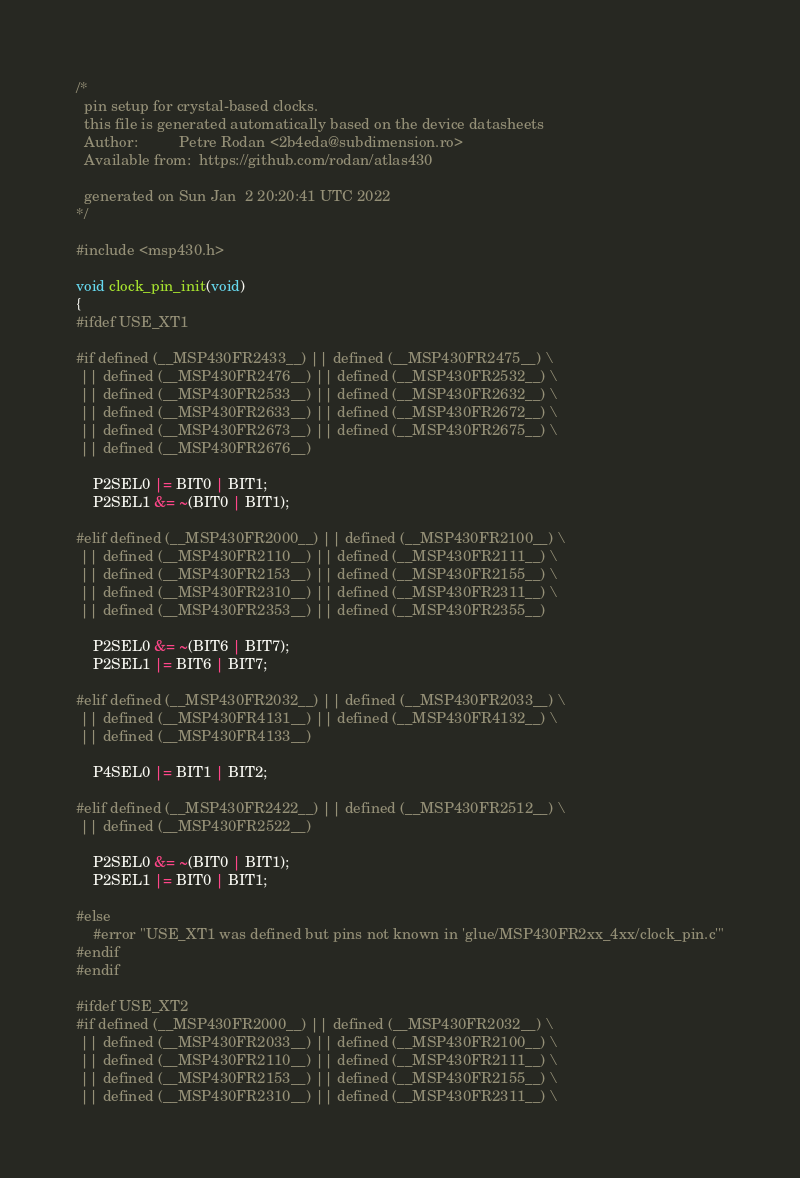<code> <loc_0><loc_0><loc_500><loc_500><_C_>/*
  pin setup for crystal-based clocks. 
  this file is generated automatically based on the device datasheets
  Author:          Petre Rodan <2b4eda@subdimension.ro>
  Available from:  https://github.com/rodan/atlas430

  generated on Sun Jan  2 20:20:41 UTC 2022
*/

#include <msp430.h>

void clock_pin_init(void)
{
#ifdef USE_XT1

#if defined (__MSP430FR2433__) || defined (__MSP430FR2475__) \
 || defined (__MSP430FR2476__) || defined (__MSP430FR2532__) \
 || defined (__MSP430FR2533__) || defined (__MSP430FR2632__) \
 || defined (__MSP430FR2633__) || defined (__MSP430FR2672__) \
 || defined (__MSP430FR2673__) || defined (__MSP430FR2675__) \
 || defined (__MSP430FR2676__)

    P2SEL0 |= BIT0 | BIT1;
    P2SEL1 &= ~(BIT0 | BIT1);

#elif defined (__MSP430FR2000__) || defined (__MSP430FR2100__) \
 || defined (__MSP430FR2110__) || defined (__MSP430FR2111__) \
 || defined (__MSP430FR2153__) || defined (__MSP430FR2155__) \
 || defined (__MSP430FR2310__) || defined (__MSP430FR2311__) \
 || defined (__MSP430FR2353__) || defined (__MSP430FR2355__)

    P2SEL0 &= ~(BIT6 | BIT7);
    P2SEL1 |= BIT6 | BIT7;

#elif defined (__MSP430FR2032__) || defined (__MSP430FR2033__) \
 || defined (__MSP430FR4131__) || defined (__MSP430FR4132__) \
 || defined (__MSP430FR4133__)

    P4SEL0 |= BIT1 | BIT2;

#elif defined (__MSP430FR2422__) || defined (__MSP430FR2512__) \
 || defined (__MSP430FR2522__)

    P2SEL0 &= ~(BIT0 | BIT1);
    P2SEL1 |= BIT0 | BIT1;

#else
    #error "USE_XT1 was defined but pins not known in 'glue/MSP430FR2xx_4xx/clock_pin.c'"
#endif
#endif

#ifdef USE_XT2
#if defined (__MSP430FR2000__) || defined (__MSP430FR2032__) \
 || defined (__MSP430FR2033__) || defined (__MSP430FR2100__) \
 || defined (__MSP430FR2110__) || defined (__MSP430FR2111__) \
 || defined (__MSP430FR2153__) || defined (__MSP430FR2155__) \
 || defined (__MSP430FR2310__) || defined (__MSP430FR2311__) \</code> 